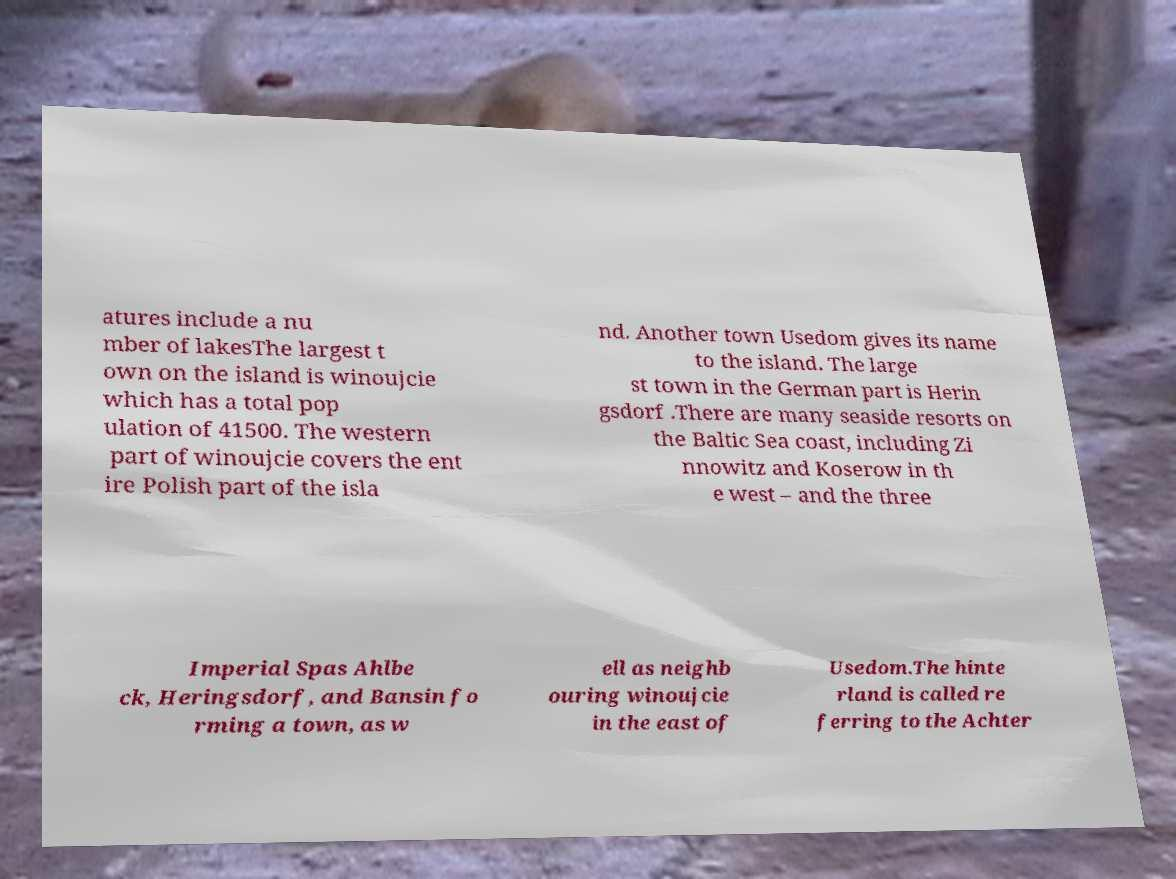Can you read and provide the text displayed in the image?This photo seems to have some interesting text. Can you extract and type it out for me? atures include a nu mber of lakesThe largest t own on the island is winoujcie which has a total pop ulation of 41500. The western part of winoujcie covers the ent ire Polish part of the isla nd. Another town Usedom gives its name to the island. The large st town in the German part is Herin gsdorf .There are many seaside resorts on the Baltic Sea coast, including Zi nnowitz and Koserow in th e west – and the three Imperial Spas Ahlbe ck, Heringsdorf, and Bansin fo rming a town, as w ell as neighb ouring winoujcie in the east of Usedom.The hinte rland is called re ferring to the Achter 